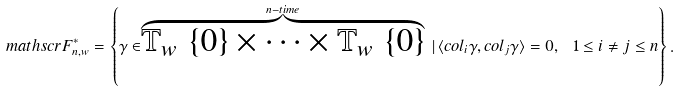Convert formula to latex. <formula><loc_0><loc_0><loc_500><loc_500>\ m a t h s c r F _ { n , w } ^ { * } = \left \{ \gamma \in \stackrel { n - t i m e } { \overbrace { \mathbb { T } _ { w } \ \{ 0 \} \times \cdots \times \mathbb { T } _ { w } \ \{ 0 \} } } \, | \, \langle c o l _ { i } { \gamma } , c o l _ { j } { \gamma } \rangle = 0 , \ 1 \leq i \neq j \leq n \right \} .</formula> 